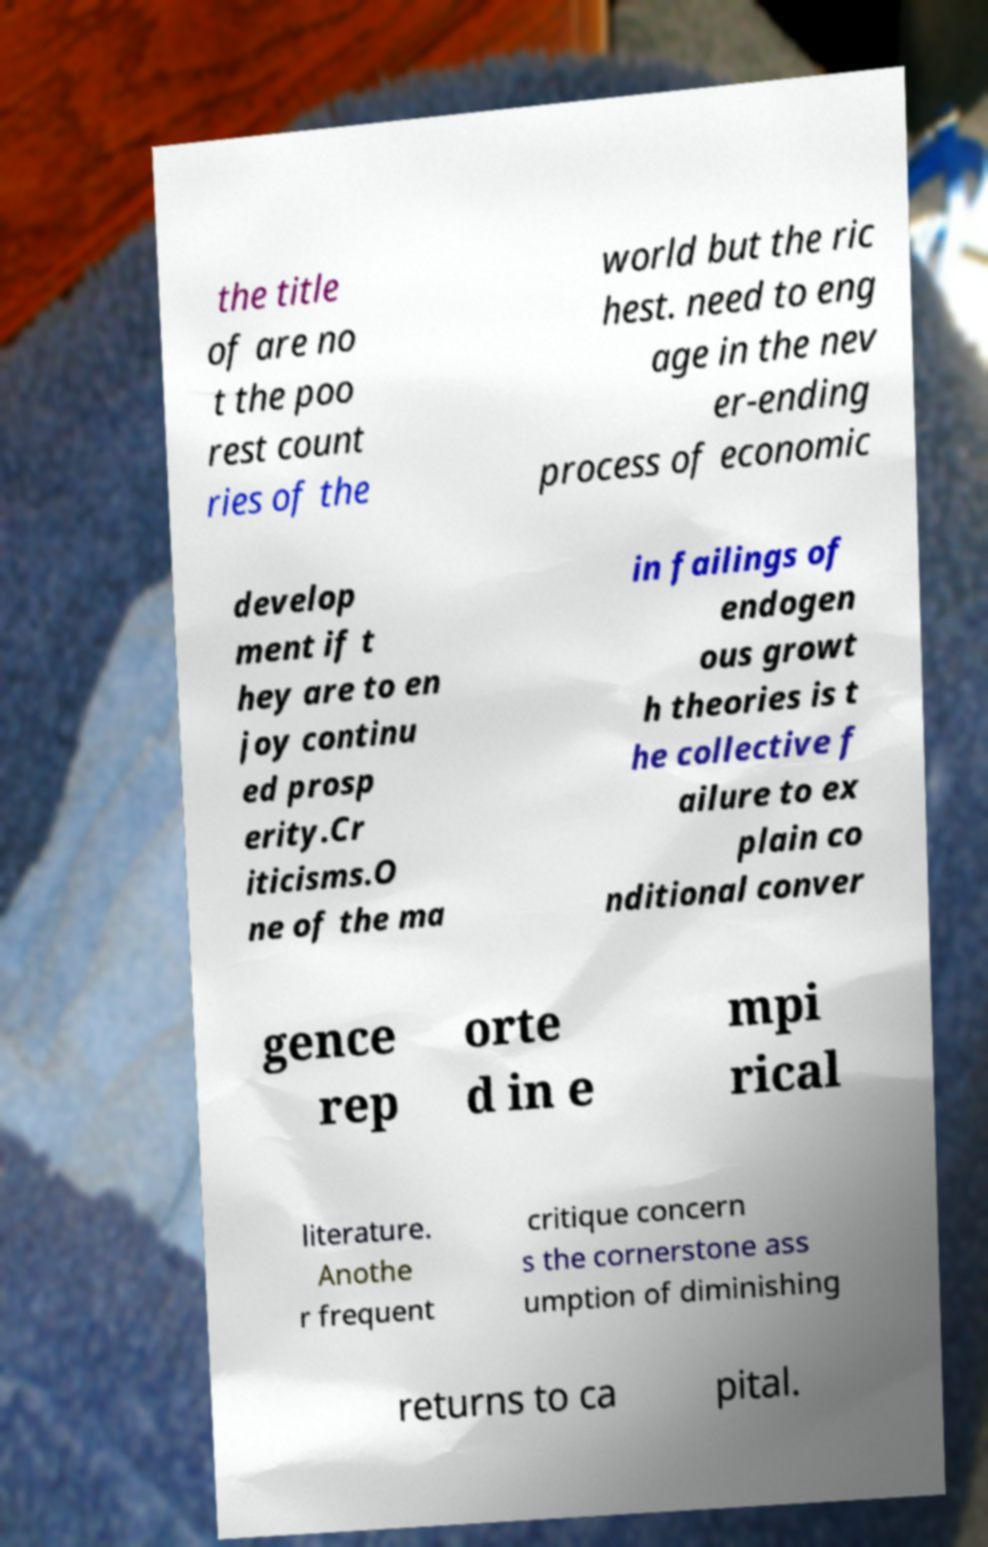Can you read and provide the text displayed in the image?This photo seems to have some interesting text. Can you extract and type it out for me? the title of are no t the poo rest count ries of the world but the ric hest. need to eng age in the nev er-ending process of economic develop ment if t hey are to en joy continu ed prosp erity.Cr iticisms.O ne of the ma in failings of endogen ous growt h theories is t he collective f ailure to ex plain co nditional conver gence rep orte d in e mpi rical literature. Anothe r frequent critique concern s the cornerstone ass umption of diminishing returns to ca pital. 